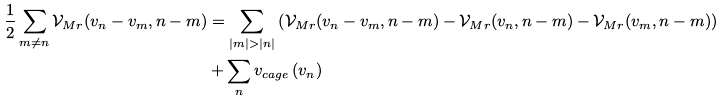Convert formula to latex. <formula><loc_0><loc_0><loc_500><loc_500>\frac { 1 } { 2 } \sum _ { m \neq n } \mathcal { V } _ { M r } ( v _ { n } - v _ { m } , n - m ) & = \sum _ { | m | > | n | } \left ( \mathcal { V } _ { M r } ( v _ { n } - v _ { m } , n - m ) - \mathcal { V } _ { M r } ( v _ { n } , n - m ) - \mathcal { V } _ { M r } ( v _ { m } , n - m ) \right ) \\ & + \sum _ { n } v _ { c a g e } \left ( v _ { n } \right )</formula> 